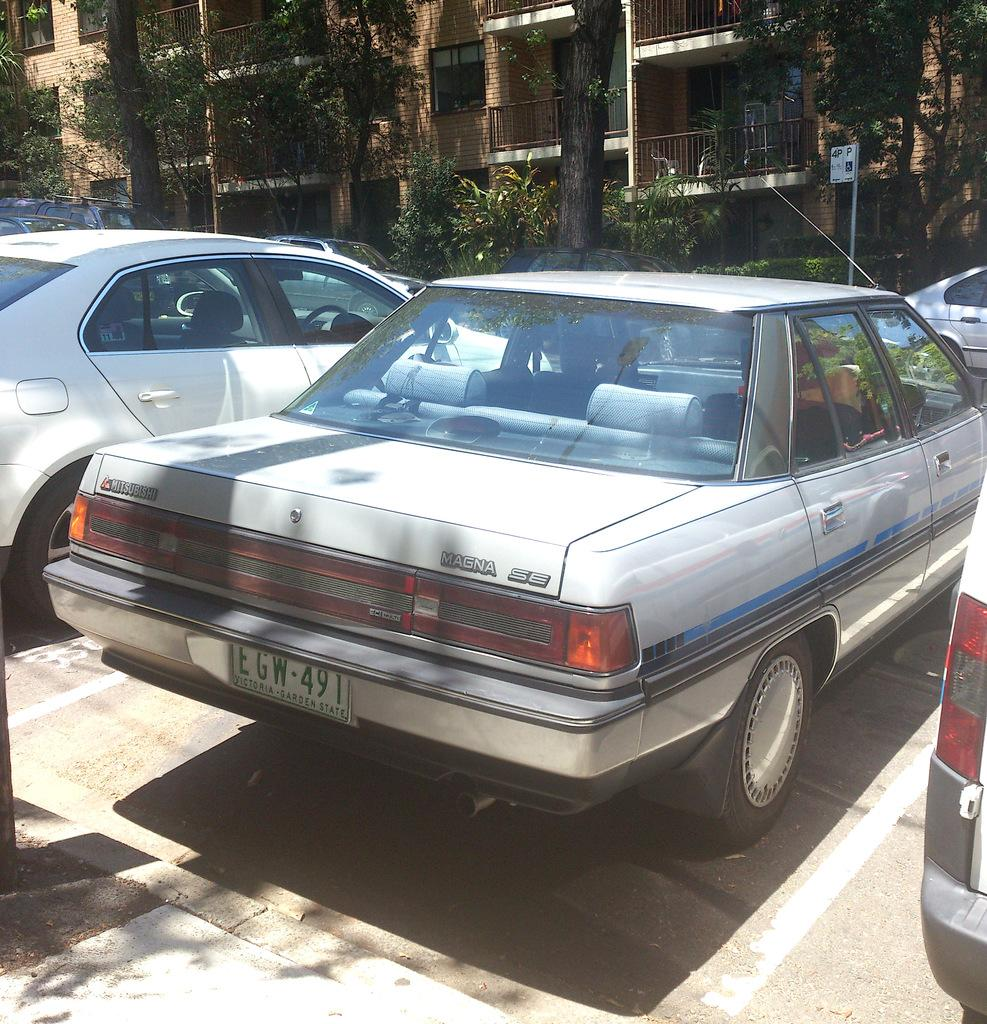What can be seen in the image related to transportation? There are vehicles parked in the image. Can you describe the background of the image? There are other vehicles parked in the background of the image. What type of vegetation is present in the image? There are plants and trees in the image. What type of structure is visible in the image? There is a building in the image. What is the condition of the sky in the image? The sky is clear in the image. What type of door can be seen on the vehicles in the image? There are no doors visible on the vehicles in the image; only the vehicles themselves are present. 